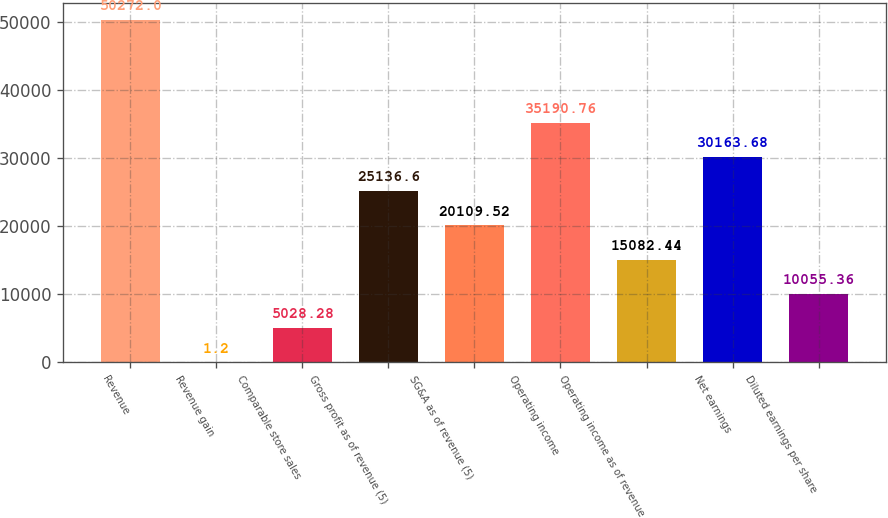Convert chart. <chart><loc_0><loc_0><loc_500><loc_500><bar_chart><fcel>Revenue<fcel>Revenue gain<fcel>Comparable store sales<fcel>Gross profit as of revenue (5)<fcel>SG&A as of revenue (5)<fcel>Operating income<fcel>Operating income as of revenue<fcel>Net earnings<fcel>Diluted earnings per share<nl><fcel>50272<fcel>1.2<fcel>5028.28<fcel>25136.6<fcel>20109.5<fcel>35190.8<fcel>15082.4<fcel>30163.7<fcel>10055.4<nl></chart> 